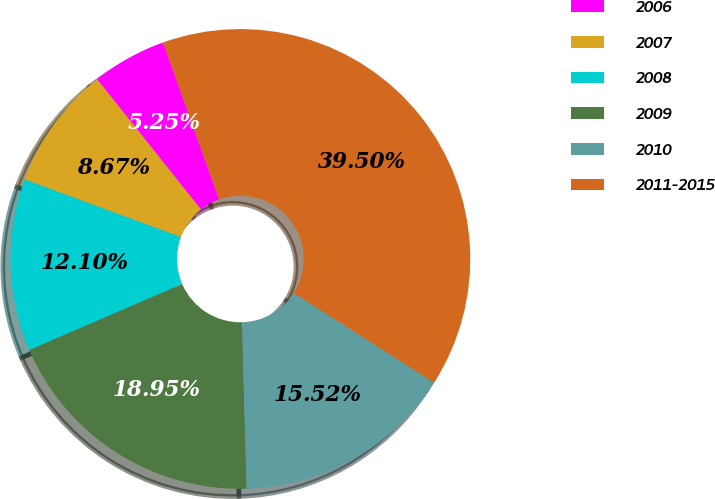Convert chart. <chart><loc_0><loc_0><loc_500><loc_500><pie_chart><fcel>2006<fcel>2007<fcel>2008<fcel>2009<fcel>2010<fcel>2011-2015<nl><fcel>5.25%<fcel>8.67%<fcel>12.1%<fcel>18.95%<fcel>15.52%<fcel>39.5%<nl></chart> 